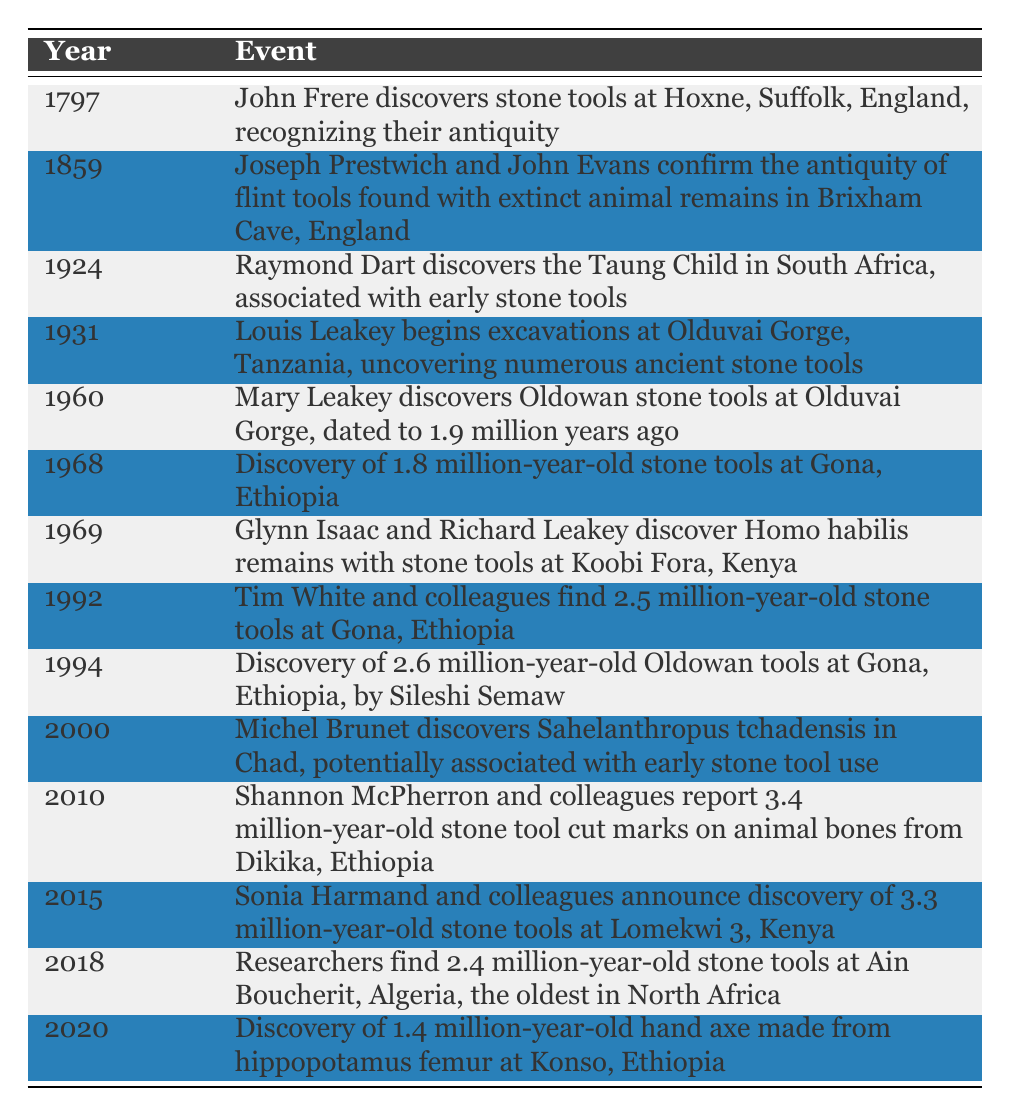What year did John Frere discover stone tools at Hoxne? The table indicates that John Frere discovered stone tools at Hoxne in the year 1797.
Answer: 1797 Which event corresponds to the year 1960? According to the table, the event that corresponds to the year 1960 is Mary Leakey discovering Oldowan stone tools at Olduvai Gorge, dated to 1.9 million years ago.
Answer: Mary Leakey discovers Oldowan stone tools at Olduvai Gorge What is the difference in years between the discovery of stone tools in Hoxne and the discovery by Joseph Prestwich and John Evans? The discovery in Hoxne occurred in 1797, and the discovery by Joseph Prestwich and John Evans was in 1859. The difference is 1859 - 1797 = 62 years.
Answer: 62 years Did any discoveries related to stone tools occur after the year 2000? By examining the table, the discoveries after 2000 are in the years 2010, 2015, 2018, and 2020, indicating that there are indeed discoveries after 2000.
Answer: Yes What is the earliest year listed in the table? The first entry in the table is from 1797, making it the earliest year listed in the chronology.
Answer: 1797 How many different locations are mentioned in the table for the discoveries of ancient stone tools? The locations mentioned are Hoxne, Brixham Cave, South Africa, Olduvai Gorge, Gona, Koobi Fora, Chad, Dikika, Lomekwi 3, and Ain Boucherit. The total count of unique locations is 9.
Answer: 9 locations What is the average age of the stone tools discovered if the ages mentioned are 1.9 million, 1.8 million, 2.5 million, 2.6 million, 3.4 million, and 3.3 million years? Adding the ages gives a total of (1.9 + 1.8 + 2.5 + 2.6 + 3.4 + 3.3) = 13.5 million years, and there are 6 data points. Thus, the average is 13.5 million / 6 = 2.25 million years.
Answer: 2.25 million years Which discovery marked the first acknowledgment of stone tools' antiquity and in what year did it happen? John Frere's discovery in 1797 signifies the first acknowledgment of stone tools' antiquity. The year is stated clearly in the table.
Answer: 1797 How many discoveries are associated with the Leakey family? The table indicates three discoveries: Louis Leakey at Olduvai Gorge in 1931, Mary Leakey discovering Oldowan tools in 1960, and Richard Leakey (with Glynn Isaac) at Koobi Fora in 1969. Therefore, there are three discoveries linked to the Leakey family.
Answer: 3 discoveries 